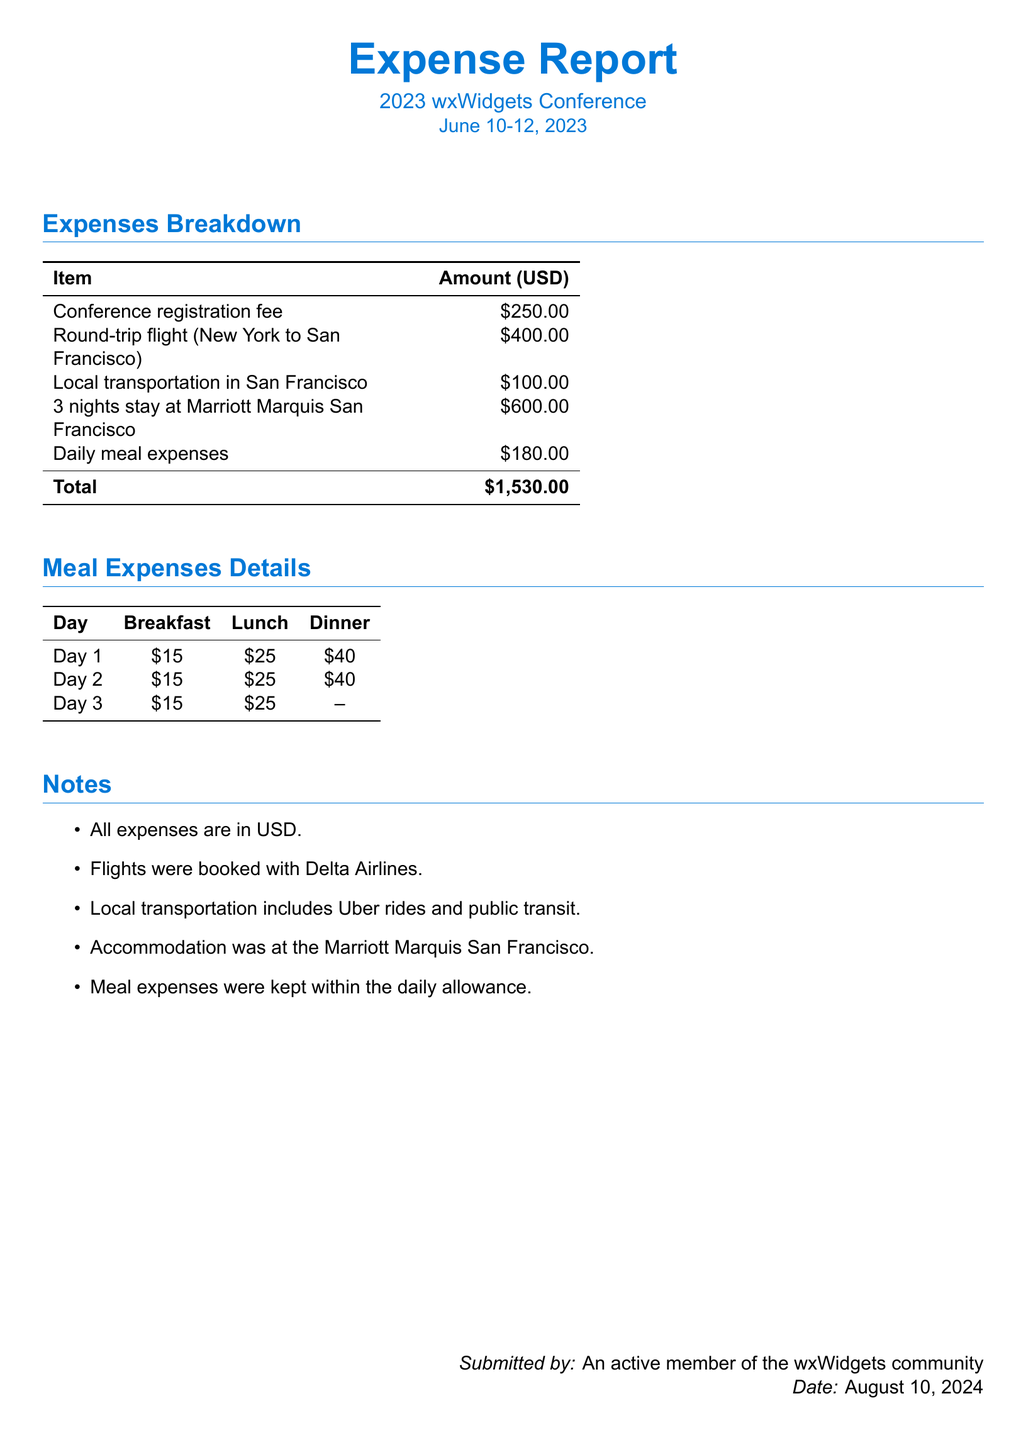What is the registration fee for the conference? The registration fee for the conference is explicitly mentioned in the expenses breakdown.
Answer: $250.00 How much was spent on the round-trip flight? The amount spent on the round-trip flight from New York to San Francisco is listed in the document.
Answer: $400.00 What was the total amount spent on accommodation? The total amount for accommodation is provided in the expenses breakdown section for the Marriott Marquis.
Answer: $600.00 What is the total expense for meals during the conference? The meal expenses are detailed for each day, and the total is derived from those amounts.
Answer: $180.00 How many nights was accommodation booked for? The number of nights for which accommodation was booked is specified in the expenses breakdown.
Answer: 3 nights What was the total amount spent on all expenses combined? The total sum of all expenses listed in the document gives the total amount.
Answer: $1,530.00 Which airline was used for the flight? The document mentions the airline booked for the flights under the notes section.
Answer: Delta Airlines Which hotel was used for accommodation? The hotel where accommodation was booked is clearly stated under the notes section.
Answer: Marriott Marquis San Francisco On which days were meals provided for dinner? The meal details show specific days with dinner expenses, allowing for reasoning to determine this.
Answer: Day 1 and Day 2 